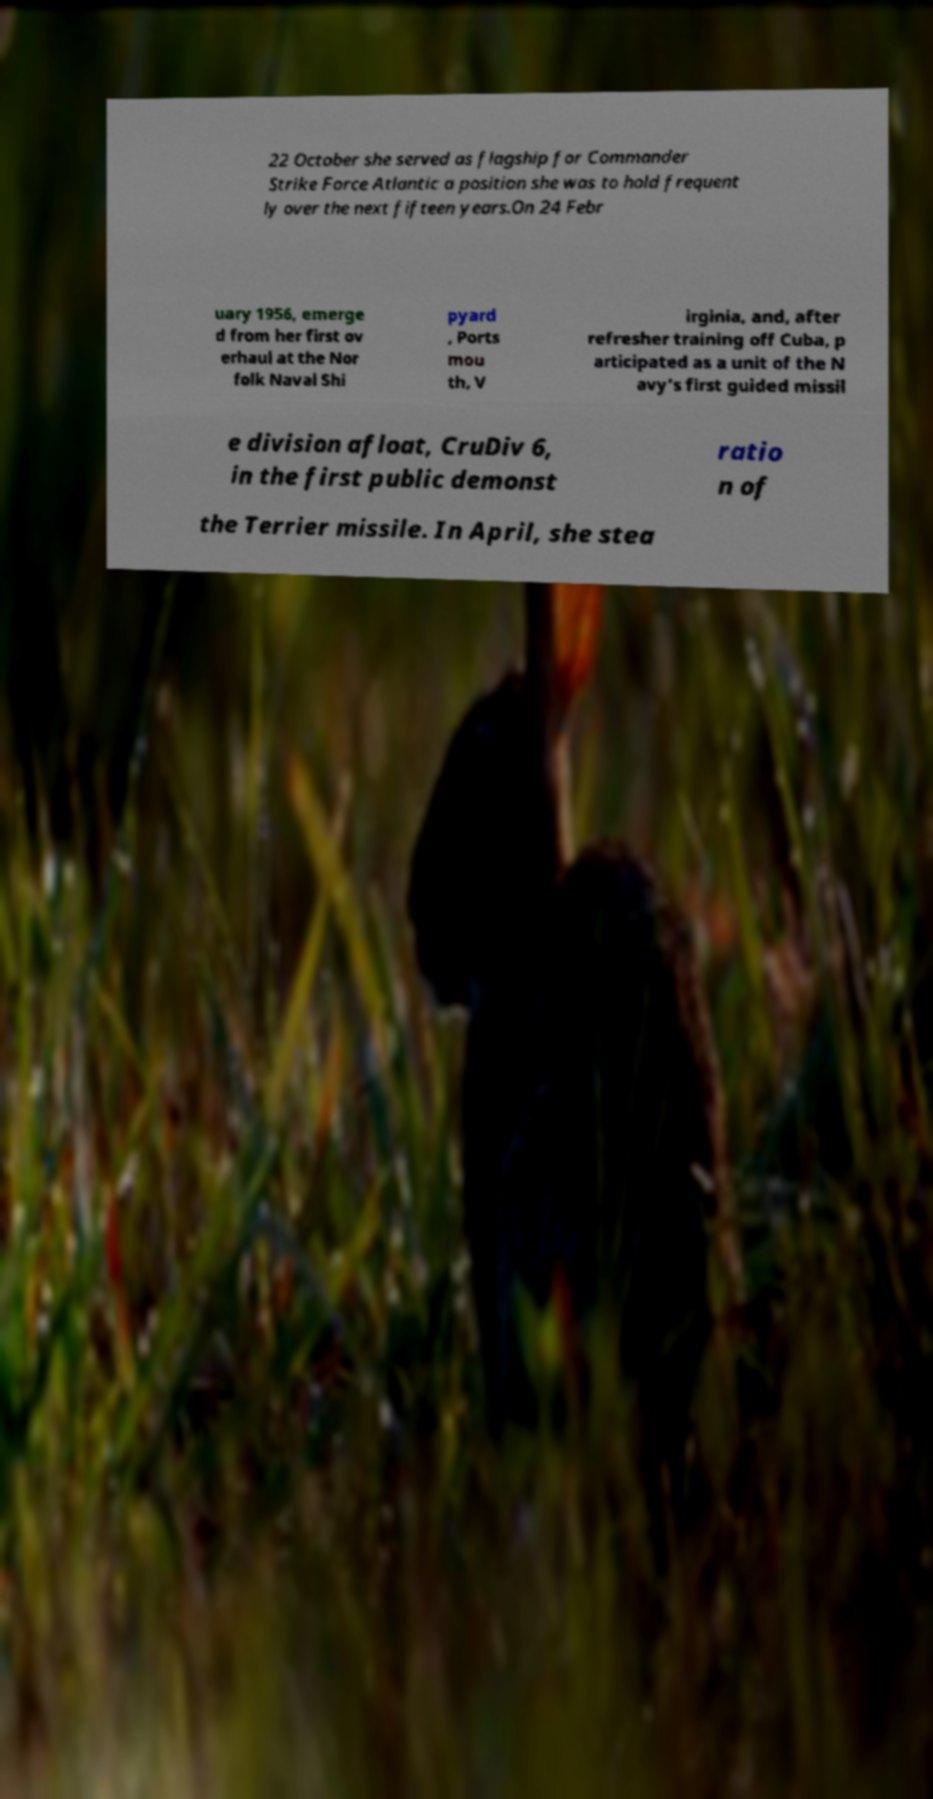I need the written content from this picture converted into text. Can you do that? 22 October she served as flagship for Commander Strike Force Atlantic a position she was to hold frequent ly over the next fifteen years.On 24 Febr uary 1956, emerge d from her first ov erhaul at the Nor folk Naval Shi pyard , Ports mou th, V irginia, and, after refresher training off Cuba, p articipated as a unit of the N avy’s first guided missil e division afloat, CruDiv 6, in the first public demonst ratio n of the Terrier missile. In April, she stea 